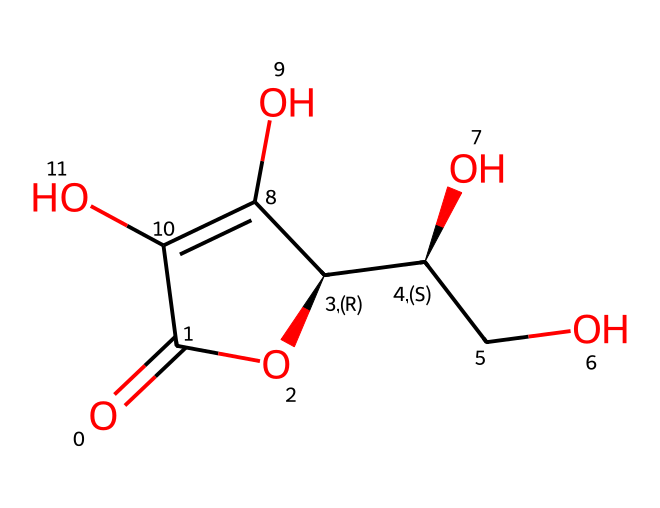What is the molecular formula of ascorbic acid? Analyzing the SMILES representation, we can determine the atoms present in the structure. Counting carbon, hydrogen, and oxygen atoms leads to the molecular formula C6H8O6.
Answer: C6H8O6 How many hydroxyl (-OH) groups are there in ascorbic acid? The chemical structure shows two hydroxyl groups explicitly, which are labeled by the oxygen atoms connected to carbon atoms.
Answer: two What is the functional group present in ascorbic acid that contributes to its antioxidant properties? The presence of hydroxyl (-OH) groups in the structure allows ascorbic acid to act as an antioxidant by donating electrons.
Answer: hydroxyl group Which part of the ascorbic acid structure indicates it can act as a preservative? The presence of the unsaturated carbonyl (C=O) and hydroxyl groups together create a redox-active site facilitating the chemical stability of food, making it indicative of preservative qualities.
Answer: carbonyl and hydroxyl groups What is the total number of oxygen atoms in ascorbic acid? Upon inspecting the chemical structure, we see that there are six oxygen atoms present in the entire molecular formula derived from the SMILES representation.
Answer: six Is ascorbic acid a natural or synthetic compound? Ascorbic acid, or Vitamin C, is naturally occurring; it is found in various fruits and vegetables and can also be synthesized.
Answer: natural 